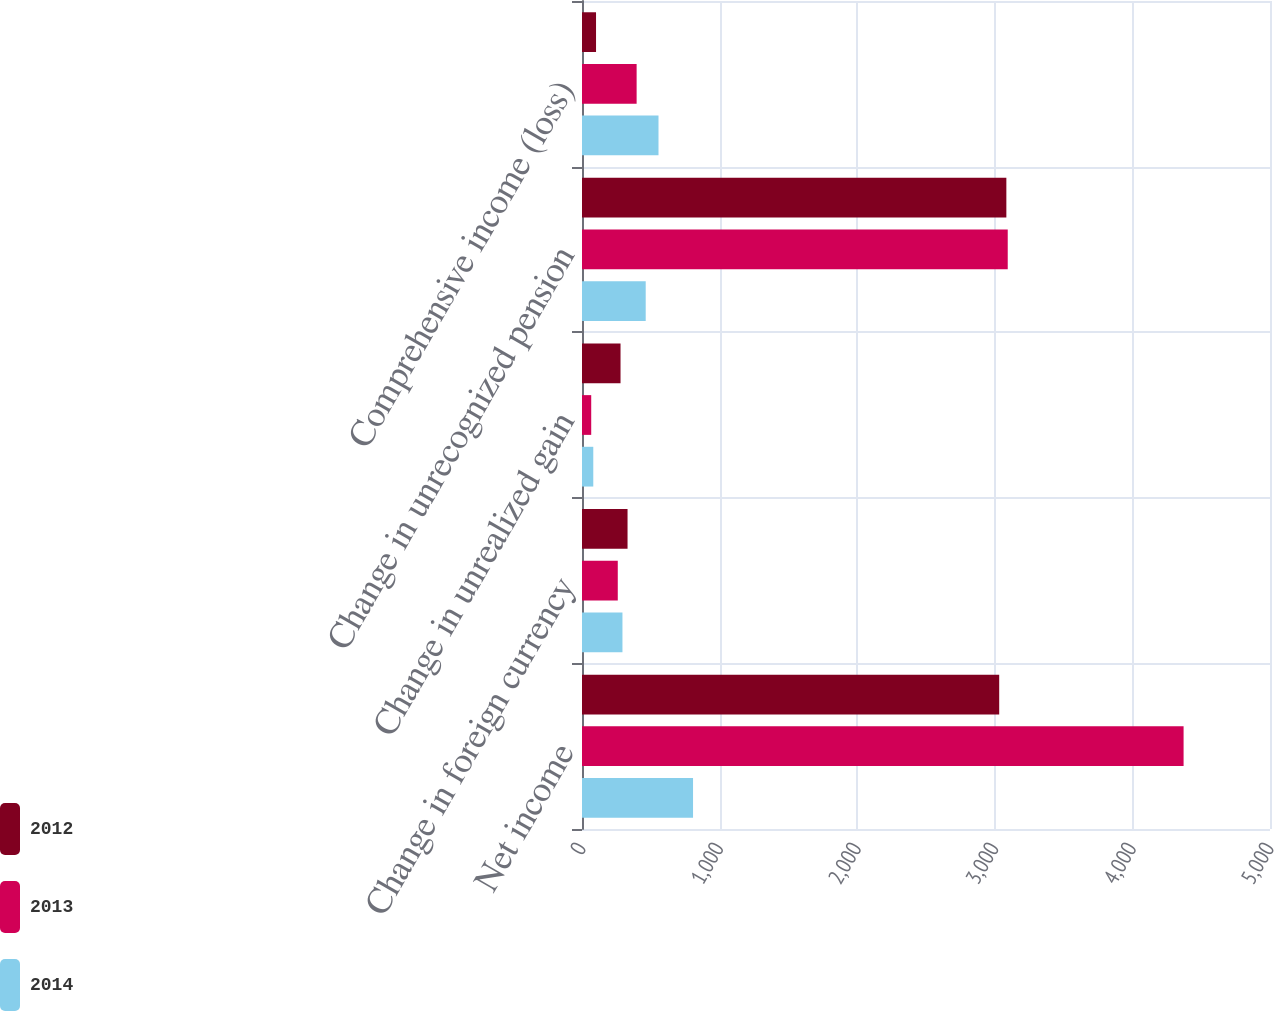Convert chart. <chart><loc_0><loc_0><loc_500><loc_500><stacked_bar_chart><ecel><fcel>Net income<fcel>Change in foreign currency<fcel>Change in unrealized gain<fcel>Change in unrecognized pension<fcel>Comprehensive income (loss)<nl><fcel>2012<fcel>3032<fcel>331<fcel>280<fcel>3084<fcel>102<nl><fcel>2013<fcel>4372<fcel>260<fcel>67<fcel>3094<fcel>397<nl><fcel>2014<fcel>807<fcel>294<fcel>82<fcel>463<fcel>556<nl></chart> 